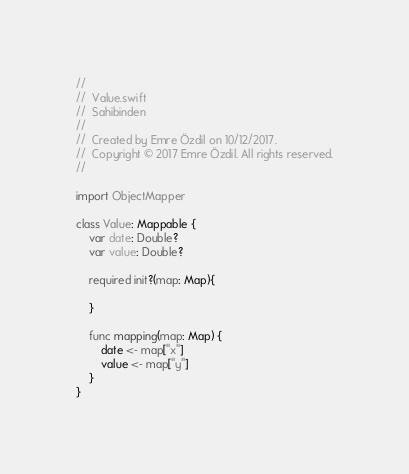Convert code to text. <code><loc_0><loc_0><loc_500><loc_500><_Swift_>//
//  Value.swift
//  Sahibinden
//
//  Created by Emre Özdil on 10/12/2017.
//  Copyright © 2017 Emre Özdil. All rights reserved.
//

import ObjectMapper

class Value: Mappable {
    var date: Double?
    var value: Double?
    
    required init?(map: Map){
        
    }
    
    func mapping(map: Map) {
        date <- map["x"]
        value <- map["y"]
    }
}
</code> 